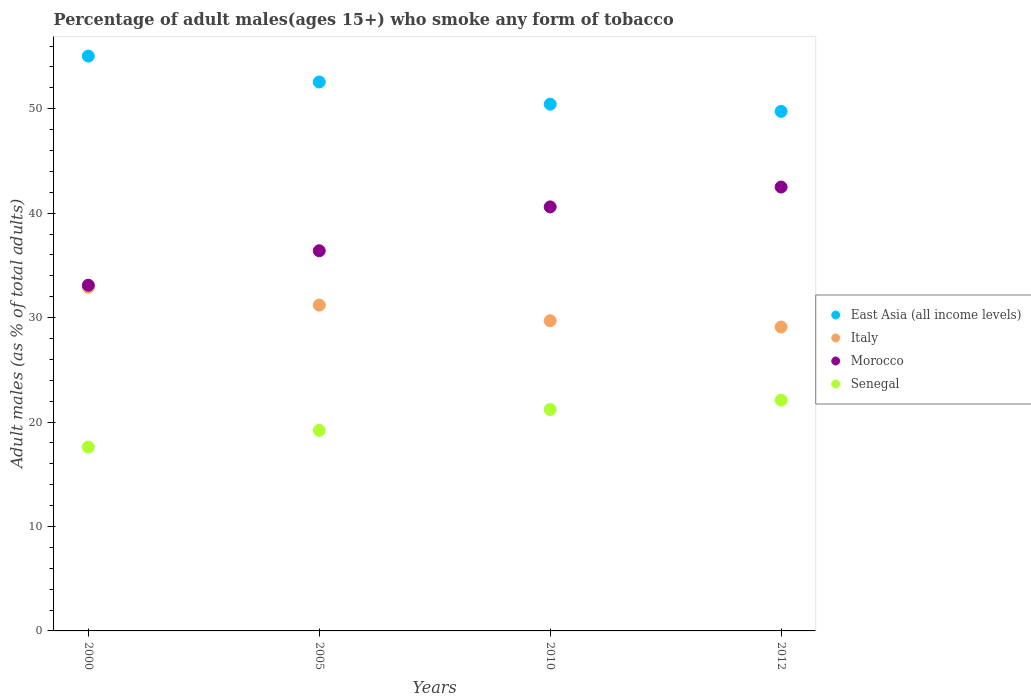What is the percentage of adult males who smoke in Senegal in 2005?
Offer a very short reply. 19.2. Across all years, what is the maximum percentage of adult males who smoke in East Asia (all income levels)?
Provide a short and direct response. 55.03. In which year was the percentage of adult males who smoke in Morocco minimum?
Make the answer very short. 2000. What is the total percentage of adult males who smoke in East Asia (all income levels) in the graph?
Provide a short and direct response. 207.77. What is the difference between the percentage of adult males who smoke in East Asia (all income levels) in 2010 and that in 2012?
Your response must be concise. 0.69. What is the difference between the percentage of adult males who smoke in East Asia (all income levels) in 2005 and the percentage of adult males who smoke in Morocco in 2010?
Your answer should be very brief. 11.96. What is the average percentage of adult males who smoke in Morocco per year?
Make the answer very short. 38.15. In how many years, is the percentage of adult males who smoke in East Asia (all income levels) greater than 34 %?
Make the answer very short. 4. What is the ratio of the percentage of adult males who smoke in Senegal in 2000 to that in 2012?
Ensure brevity in your answer.  0.8. Is the percentage of adult males who smoke in East Asia (all income levels) in 2005 less than that in 2012?
Offer a very short reply. No. Is the difference between the percentage of adult males who smoke in Senegal in 2005 and 2012 greater than the difference between the percentage of adult males who smoke in Italy in 2005 and 2012?
Make the answer very short. No. What is the difference between the highest and the second highest percentage of adult males who smoke in Senegal?
Offer a very short reply. 0.9. What is the difference between the highest and the lowest percentage of adult males who smoke in Italy?
Your answer should be very brief. 3.8. Is the sum of the percentage of adult males who smoke in Senegal in 2000 and 2005 greater than the maximum percentage of adult males who smoke in Italy across all years?
Your answer should be compact. Yes. Does the percentage of adult males who smoke in Italy monotonically increase over the years?
Provide a succinct answer. No. Is the percentage of adult males who smoke in East Asia (all income levels) strictly greater than the percentage of adult males who smoke in Morocco over the years?
Provide a short and direct response. Yes. Does the graph contain any zero values?
Offer a very short reply. No. Does the graph contain grids?
Provide a succinct answer. No. How many legend labels are there?
Give a very brief answer. 4. How are the legend labels stacked?
Make the answer very short. Vertical. What is the title of the graph?
Give a very brief answer. Percentage of adult males(ages 15+) who smoke any form of tobacco. Does "Japan" appear as one of the legend labels in the graph?
Offer a very short reply. No. What is the label or title of the X-axis?
Provide a short and direct response. Years. What is the label or title of the Y-axis?
Your answer should be compact. Adult males (as % of total adults). What is the Adult males (as % of total adults) of East Asia (all income levels) in 2000?
Make the answer very short. 55.03. What is the Adult males (as % of total adults) of Italy in 2000?
Give a very brief answer. 32.9. What is the Adult males (as % of total adults) in Morocco in 2000?
Keep it short and to the point. 33.1. What is the Adult males (as % of total adults) of East Asia (all income levels) in 2005?
Offer a terse response. 52.56. What is the Adult males (as % of total adults) in Italy in 2005?
Keep it short and to the point. 31.2. What is the Adult males (as % of total adults) in Morocco in 2005?
Provide a succinct answer. 36.4. What is the Adult males (as % of total adults) in East Asia (all income levels) in 2010?
Provide a succinct answer. 50.43. What is the Adult males (as % of total adults) in Italy in 2010?
Keep it short and to the point. 29.7. What is the Adult males (as % of total adults) of Morocco in 2010?
Keep it short and to the point. 40.6. What is the Adult males (as % of total adults) in Senegal in 2010?
Give a very brief answer. 21.2. What is the Adult males (as % of total adults) of East Asia (all income levels) in 2012?
Provide a succinct answer. 49.74. What is the Adult males (as % of total adults) of Italy in 2012?
Your answer should be compact. 29.1. What is the Adult males (as % of total adults) of Morocco in 2012?
Your answer should be compact. 42.5. What is the Adult males (as % of total adults) of Senegal in 2012?
Offer a very short reply. 22.1. Across all years, what is the maximum Adult males (as % of total adults) of East Asia (all income levels)?
Provide a succinct answer. 55.03. Across all years, what is the maximum Adult males (as % of total adults) in Italy?
Offer a terse response. 32.9. Across all years, what is the maximum Adult males (as % of total adults) in Morocco?
Your answer should be compact. 42.5. Across all years, what is the maximum Adult males (as % of total adults) of Senegal?
Ensure brevity in your answer.  22.1. Across all years, what is the minimum Adult males (as % of total adults) in East Asia (all income levels)?
Offer a terse response. 49.74. Across all years, what is the minimum Adult males (as % of total adults) in Italy?
Your response must be concise. 29.1. Across all years, what is the minimum Adult males (as % of total adults) of Morocco?
Give a very brief answer. 33.1. Across all years, what is the minimum Adult males (as % of total adults) in Senegal?
Make the answer very short. 17.6. What is the total Adult males (as % of total adults) in East Asia (all income levels) in the graph?
Your answer should be compact. 207.77. What is the total Adult males (as % of total adults) in Italy in the graph?
Make the answer very short. 122.9. What is the total Adult males (as % of total adults) of Morocco in the graph?
Offer a terse response. 152.6. What is the total Adult males (as % of total adults) of Senegal in the graph?
Your answer should be very brief. 80.1. What is the difference between the Adult males (as % of total adults) of East Asia (all income levels) in 2000 and that in 2005?
Offer a terse response. 2.48. What is the difference between the Adult males (as % of total adults) in Morocco in 2000 and that in 2005?
Keep it short and to the point. -3.3. What is the difference between the Adult males (as % of total adults) of East Asia (all income levels) in 2000 and that in 2010?
Keep it short and to the point. 4.6. What is the difference between the Adult males (as % of total adults) of East Asia (all income levels) in 2000 and that in 2012?
Make the answer very short. 5.29. What is the difference between the Adult males (as % of total adults) of Italy in 2000 and that in 2012?
Provide a succinct answer. 3.8. What is the difference between the Adult males (as % of total adults) of Morocco in 2000 and that in 2012?
Offer a very short reply. -9.4. What is the difference between the Adult males (as % of total adults) of Senegal in 2000 and that in 2012?
Offer a terse response. -4.5. What is the difference between the Adult males (as % of total adults) of East Asia (all income levels) in 2005 and that in 2010?
Provide a succinct answer. 2.13. What is the difference between the Adult males (as % of total adults) of Italy in 2005 and that in 2010?
Your response must be concise. 1.5. What is the difference between the Adult males (as % of total adults) in Morocco in 2005 and that in 2010?
Provide a short and direct response. -4.2. What is the difference between the Adult males (as % of total adults) in East Asia (all income levels) in 2005 and that in 2012?
Give a very brief answer. 2.81. What is the difference between the Adult males (as % of total adults) of Italy in 2005 and that in 2012?
Your answer should be compact. 2.1. What is the difference between the Adult males (as % of total adults) in Morocco in 2005 and that in 2012?
Provide a short and direct response. -6.1. What is the difference between the Adult males (as % of total adults) in East Asia (all income levels) in 2010 and that in 2012?
Provide a short and direct response. 0.69. What is the difference between the Adult males (as % of total adults) in Italy in 2010 and that in 2012?
Your answer should be compact. 0.6. What is the difference between the Adult males (as % of total adults) of Morocco in 2010 and that in 2012?
Offer a terse response. -1.9. What is the difference between the Adult males (as % of total adults) of East Asia (all income levels) in 2000 and the Adult males (as % of total adults) of Italy in 2005?
Make the answer very short. 23.83. What is the difference between the Adult males (as % of total adults) of East Asia (all income levels) in 2000 and the Adult males (as % of total adults) of Morocco in 2005?
Make the answer very short. 18.63. What is the difference between the Adult males (as % of total adults) of East Asia (all income levels) in 2000 and the Adult males (as % of total adults) of Senegal in 2005?
Keep it short and to the point. 35.83. What is the difference between the Adult males (as % of total adults) of Italy in 2000 and the Adult males (as % of total adults) of Morocco in 2005?
Give a very brief answer. -3.5. What is the difference between the Adult males (as % of total adults) in Italy in 2000 and the Adult males (as % of total adults) in Senegal in 2005?
Offer a terse response. 13.7. What is the difference between the Adult males (as % of total adults) of East Asia (all income levels) in 2000 and the Adult males (as % of total adults) of Italy in 2010?
Provide a succinct answer. 25.33. What is the difference between the Adult males (as % of total adults) of East Asia (all income levels) in 2000 and the Adult males (as % of total adults) of Morocco in 2010?
Give a very brief answer. 14.43. What is the difference between the Adult males (as % of total adults) in East Asia (all income levels) in 2000 and the Adult males (as % of total adults) in Senegal in 2010?
Give a very brief answer. 33.83. What is the difference between the Adult males (as % of total adults) in Italy in 2000 and the Adult males (as % of total adults) in Morocco in 2010?
Give a very brief answer. -7.7. What is the difference between the Adult males (as % of total adults) of Morocco in 2000 and the Adult males (as % of total adults) of Senegal in 2010?
Ensure brevity in your answer.  11.9. What is the difference between the Adult males (as % of total adults) of East Asia (all income levels) in 2000 and the Adult males (as % of total adults) of Italy in 2012?
Your response must be concise. 25.93. What is the difference between the Adult males (as % of total adults) in East Asia (all income levels) in 2000 and the Adult males (as % of total adults) in Morocco in 2012?
Offer a very short reply. 12.53. What is the difference between the Adult males (as % of total adults) in East Asia (all income levels) in 2000 and the Adult males (as % of total adults) in Senegal in 2012?
Keep it short and to the point. 32.93. What is the difference between the Adult males (as % of total adults) in East Asia (all income levels) in 2005 and the Adult males (as % of total adults) in Italy in 2010?
Offer a terse response. 22.86. What is the difference between the Adult males (as % of total adults) of East Asia (all income levels) in 2005 and the Adult males (as % of total adults) of Morocco in 2010?
Offer a very short reply. 11.96. What is the difference between the Adult males (as % of total adults) in East Asia (all income levels) in 2005 and the Adult males (as % of total adults) in Senegal in 2010?
Your answer should be very brief. 31.36. What is the difference between the Adult males (as % of total adults) of Italy in 2005 and the Adult males (as % of total adults) of Morocco in 2010?
Offer a terse response. -9.4. What is the difference between the Adult males (as % of total adults) of Italy in 2005 and the Adult males (as % of total adults) of Senegal in 2010?
Offer a terse response. 10. What is the difference between the Adult males (as % of total adults) in Morocco in 2005 and the Adult males (as % of total adults) in Senegal in 2010?
Ensure brevity in your answer.  15.2. What is the difference between the Adult males (as % of total adults) in East Asia (all income levels) in 2005 and the Adult males (as % of total adults) in Italy in 2012?
Offer a very short reply. 23.46. What is the difference between the Adult males (as % of total adults) in East Asia (all income levels) in 2005 and the Adult males (as % of total adults) in Morocco in 2012?
Keep it short and to the point. 10.06. What is the difference between the Adult males (as % of total adults) of East Asia (all income levels) in 2005 and the Adult males (as % of total adults) of Senegal in 2012?
Make the answer very short. 30.46. What is the difference between the Adult males (as % of total adults) of Italy in 2005 and the Adult males (as % of total adults) of Morocco in 2012?
Ensure brevity in your answer.  -11.3. What is the difference between the Adult males (as % of total adults) in Italy in 2005 and the Adult males (as % of total adults) in Senegal in 2012?
Your response must be concise. 9.1. What is the difference between the Adult males (as % of total adults) in East Asia (all income levels) in 2010 and the Adult males (as % of total adults) in Italy in 2012?
Offer a very short reply. 21.33. What is the difference between the Adult males (as % of total adults) of East Asia (all income levels) in 2010 and the Adult males (as % of total adults) of Morocco in 2012?
Make the answer very short. 7.93. What is the difference between the Adult males (as % of total adults) of East Asia (all income levels) in 2010 and the Adult males (as % of total adults) of Senegal in 2012?
Provide a succinct answer. 28.33. What is the difference between the Adult males (as % of total adults) of Italy in 2010 and the Adult males (as % of total adults) of Morocco in 2012?
Offer a terse response. -12.8. What is the difference between the Adult males (as % of total adults) in Italy in 2010 and the Adult males (as % of total adults) in Senegal in 2012?
Your answer should be compact. 7.6. What is the average Adult males (as % of total adults) of East Asia (all income levels) per year?
Provide a short and direct response. 51.94. What is the average Adult males (as % of total adults) in Italy per year?
Provide a short and direct response. 30.73. What is the average Adult males (as % of total adults) in Morocco per year?
Provide a short and direct response. 38.15. What is the average Adult males (as % of total adults) of Senegal per year?
Ensure brevity in your answer.  20.02. In the year 2000, what is the difference between the Adult males (as % of total adults) in East Asia (all income levels) and Adult males (as % of total adults) in Italy?
Your response must be concise. 22.13. In the year 2000, what is the difference between the Adult males (as % of total adults) of East Asia (all income levels) and Adult males (as % of total adults) of Morocco?
Provide a succinct answer. 21.93. In the year 2000, what is the difference between the Adult males (as % of total adults) of East Asia (all income levels) and Adult males (as % of total adults) of Senegal?
Offer a very short reply. 37.43. In the year 2000, what is the difference between the Adult males (as % of total adults) of Italy and Adult males (as % of total adults) of Morocco?
Provide a short and direct response. -0.2. In the year 2000, what is the difference between the Adult males (as % of total adults) of Morocco and Adult males (as % of total adults) of Senegal?
Keep it short and to the point. 15.5. In the year 2005, what is the difference between the Adult males (as % of total adults) in East Asia (all income levels) and Adult males (as % of total adults) in Italy?
Give a very brief answer. 21.36. In the year 2005, what is the difference between the Adult males (as % of total adults) in East Asia (all income levels) and Adult males (as % of total adults) in Morocco?
Your answer should be very brief. 16.16. In the year 2005, what is the difference between the Adult males (as % of total adults) in East Asia (all income levels) and Adult males (as % of total adults) in Senegal?
Your response must be concise. 33.36. In the year 2005, what is the difference between the Adult males (as % of total adults) in Italy and Adult males (as % of total adults) in Morocco?
Provide a succinct answer. -5.2. In the year 2005, what is the difference between the Adult males (as % of total adults) of Morocco and Adult males (as % of total adults) of Senegal?
Provide a succinct answer. 17.2. In the year 2010, what is the difference between the Adult males (as % of total adults) in East Asia (all income levels) and Adult males (as % of total adults) in Italy?
Your answer should be very brief. 20.73. In the year 2010, what is the difference between the Adult males (as % of total adults) of East Asia (all income levels) and Adult males (as % of total adults) of Morocco?
Make the answer very short. 9.83. In the year 2010, what is the difference between the Adult males (as % of total adults) of East Asia (all income levels) and Adult males (as % of total adults) of Senegal?
Keep it short and to the point. 29.23. In the year 2010, what is the difference between the Adult males (as % of total adults) in Italy and Adult males (as % of total adults) in Morocco?
Give a very brief answer. -10.9. In the year 2012, what is the difference between the Adult males (as % of total adults) of East Asia (all income levels) and Adult males (as % of total adults) of Italy?
Ensure brevity in your answer.  20.64. In the year 2012, what is the difference between the Adult males (as % of total adults) in East Asia (all income levels) and Adult males (as % of total adults) in Morocco?
Keep it short and to the point. 7.24. In the year 2012, what is the difference between the Adult males (as % of total adults) of East Asia (all income levels) and Adult males (as % of total adults) of Senegal?
Offer a very short reply. 27.64. In the year 2012, what is the difference between the Adult males (as % of total adults) in Italy and Adult males (as % of total adults) in Senegal?
Ensure brevity in your answer.  7. In the year 2012, what is the difference between the Adult males (as % of total adults) of Morocco and Adult males (as % of total adults) of Senegal?
Ensure brevity in your answer.  20.4. What is the ratio of the Adult males (as % of total adults) of East Asia (all income levels) in 2000 to that in 2005?
Your answer should be compact. 1.05. What is the ratio of the Adult males (as % of total adults) in Italy in 2000 to that in 2005?
Provide a succinct answer. 1.05. What is the ratio of the Adult males (as % of total adults) in Morocco in 2000 to that in 2005?
Your response must be concise. 0.91. What is the ratio of the Adult males (as % of total adults) in East Asia (all income levels) in 2000 to that in 2010?
Ensure brevity in your answer.  1.09. What is the ratio of the Adult males (as % of total adults) of Italy in 2000 to that in 2010?
Ensure brevity in your answer.  1.11. What is the ratio of the Adult males (as % of total adults) of Morocco in 2000 to that in 2010?
Offer a very short reply. 0.82. What is the ratio of the Adult males (as % of total adults) of Senegal in 2000 to that in 2010?
Your answer should be compact. 0.83. What is the ratio of the Adult males (as % of total adults) in East Asia (all income levels) in 2000 to that in 2012?
Your answer should be very brief. 1.11. What is the ratio of the Adult males (as % of total adults) of Italy in 2000 to that in 2012?
Your answer should be compact. 1.13. What is the ratio of the Adult males (as % of total adults) of Morocco in 2000 to that in 2012?
Provide a short and direct response. 0.78. What is the ratio of the Adult males (as % of total adults) in Senegal in 2000 to that in 2012?
Make the answer very short. 0.8. What is the ratio of the Adult males (as % of total adults) in East Asia (all income levels) in 2005 to that in 2010?
Offer a very short reply. 1.04. What is the ratio of the Adult males (as % of total adults) in Italy in 2005 to that in 2010?
Your answer should be very brief. 1.05. What is the ratio of the Adult males (as % of total adults) in Morocco in 2005 to that in 2010?
Your answer should be very brief. 0.9. What is the ratio of the Adult males (as % of total adults) in Senegal in 2005 to that in 2010?
Your response must be concise. 0.91. What is the ratio of the Adult males (as % of total adults) of East Asia (all income levels) in 2005 to that in 2012?
Provide a short and direct response. 1.06. What is the ratio of the Adult males (as % of total adults) of Italy in 2005 to that in 2012?
Offer a very short reply. 1.07. What is the ratio of the Adult males (as % of total adults) in Morocco in 2005 to that in 2012?
Offer a terse response. 0.86. What is the ratio of the Adult males (as % of total adults) in Senegal in 2005 to that in 2012?
Ensure brevity in your answer.  0.87. What is the ratio of the Adult males (as % of total adults) of East Asia (all income levels) in 2010 to that in 2012?
Offer a terse response. 1.01. What is the ratio of the Adult males (as % of total adults) of Italy in 2010 to that in 2012?
Offer a terse response. 1.02. What is the ratio of the Adult males (as % of total adults) in Morocco in 2010 to that in 2012?
Your response must be concise. 0.96. What is the ratio of the Adult males (as % of total adults) of Senegal in 2010 to that in 2012?
Your response must be concise. 0.96. What is the difference between the highest and the second highest Adult males (as % of total adults) of East Asia (all income levels)?
Make the answer very short. 2.48. What is the difference between the highest and the second highest Adult males (as % of total adults) of Italy?
Give a very brief answer. 1.7. What is the difference between the highest and the second highest Adult males (as % of total adults) of Morocco?
Provide a short and direct response. 1.9. What is the difference between the highest and the second highest Adult males (as % of total adults) in Senegal?
Your answer should be compact. 0.9. What is the difference between the highest and the lowest Adult males (as % of total adults) of East Asia (all income levels)?
Ensure brevity in your answer.  5.29. What is the difference between the highest and the lowest Adult males (as % of total adults) of Italy?
Provide a short and direct response. 3.8. What is the difference between the highest and the lowest Adult males (as % of total adults) of Morocco?
Your answer should be very brief. 9.4. What is the difference between the highest and the lowest Adult males (as % of total adults) in Senegal?
Keep it short and to the point. 4.5. 